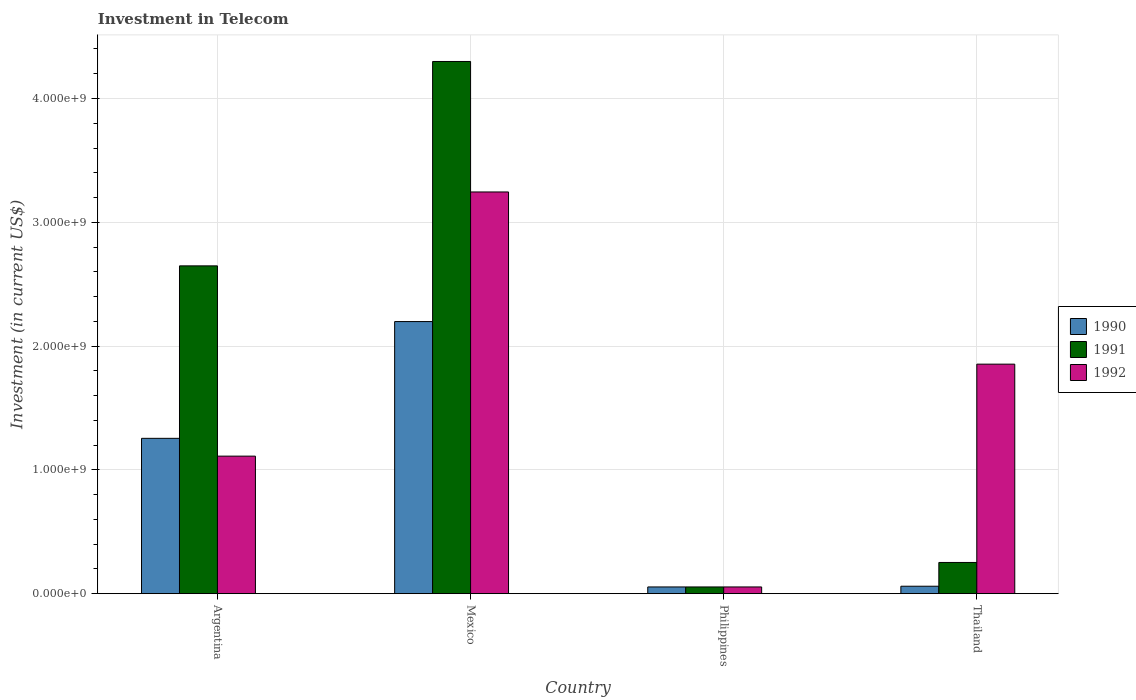Are the number of bars per tick equal to the number of legend labels?
Ensure brevity in your answer.  Yes. Are the number of bars on each tick of the X-axis equal?
Your response must be concise. Yes. How many bars are there on the 2nd tick from the right?
Your answer should be compact. 3. What is the amount invested in telecom in 1990 in Argentina?
Ensure brevity in your answer.  1.25e+09. Across all countries, what is the maximum amount invested in telecom in 1990?
Keep it short and to the point. 2.20e+09. Across all countries, what is the minimum amount invested in telecom in 1991?
Offer a very short reply. 5.42e+07. In which country was the amount invested in telecom in 1992 maximum?
Your answer should be compact. Mexico. In which country was the amount invested in telecom in 1990 minimum?
Ensure brevity in your answer.  Philippines. What is the total amount invested in telecom in 1992 in the graph?
Make the answer very short. 6.26e+09. What is the difference between the amount invested in telecom in 1991 in Mexico and that in Thailand?
Your response must be concise. 4.05e+09. What is the difference between the amount invested in telecom in 1991 in Thailand and the amount invested in telecom in 1992 in Mexico?
Offer a very short reply. -2.99e+09. What is the average amount invested in telecom in 1990 per country?
Provide a short and direct response. 8.92e+08. What is the difference between the amount invested in telecom of/in 1990 and amount invested in telecom of/in 1991 in Argentina?
Provide a succinct answer. -1.39e+09. In how many countries, is the amount invested in telecom in 1992 greater than 3200000000 US$?
Make the answer very short. 1. What is the ratio of the amount invested in telecom in 1992 in Argentina to that in Thailand?
Give a very brief answer. 0.6. Is the amount invested in telecom in 1990 in Philippines less than that in Thailand?
Your answer should be compact. Yes. Is the difference between the amount invested in telecom in 1990 in Argentina and Philippines greater than the difference between the amount invested in telecom in 1991 in Argentina and Philippines?
Your answer should be compact. No. What is the difference between the highest and the second highest amount invested in telecom in 1990?
Make the answer very short. 2.14e+09. What is the difference between the highest and the lowest amount invested in telecom in 1992?
Ensure brevity in your answer.  3.19e+09. Is it the case that in every country, the sum of the amount invested in telecom in 1992 and amount invested in telecom in 1990 is greater than the amount invested in telecom in 1991?
Ensure brevity in your answer.  No. What is the difference between two consecutive major ticks on the Y-axis?
Offer a very short reply. 1.00e+09. Are the values on the major ticks of Y-axis written in scientific E-notation?
Offer a very short reply. Yes. Does the graph contain grids?
Provide a succinct answer. Yes. What is the title of the graph?
Provide a succinct answer. Investment in Telecom. Does "2009" appear as one of the legend labels in the graph?
Offer a very short reply. No. What is the label or title of the X-axis?
Your answer should be compact. Country. What is the label or title of the Y-axis?
Offer a very short reply. Investment (in current US$). What is the Investment (in current US$) in 1990 in Argentina?
Offer a terse response. 1.25e+09. What is the Investment (in current US$) of 1991 in Argentina?
Your answer should be compact. 2.65e+09. What is the Investment (in current US$) in 1992 in Argentina?
Your answer should be compact. 1.11e+09. What is the Investment (in current US$) in 1990 in Mexico?
Give a very brief answer. 2.20e+09. What is the Investment (in current US$) in 1991 in Mexico?
Provide a short and direct response. 4.30e+09. What is the Investment (in current US$) in 1992 in Mexico?
Offer a terse response. 3.24e+09. What is the Investment (in current US$) in 1990 in Philippines?
Provide a succinct answer. 5.42e+07. What is the Investment (in current US$) of 1991 in Philippines?
Your answer should be very brief. 5.42e+07. What is the Investment (in current US$) in 1992 in Philippines?
Ensure brevity in your answer.  5.42e+07. What is the Investment (in current US$) of 1990 in Thailand?
Your response must be concise. 6.00e+07. What is the Investment (in current US$) in 1991 in Thailand?
Provide a succinct answer. 2.52e+08. What is the Investment (in current US$) in 1992 in Thailand?
Offer a terse response. 1.85e+09. Across all countries, what is the maximum Investment (in current US$) in 1990?
Your response must be concise. 2.20e+09. Across all countries, what is the maximum Investment (in current US$) in 1991?
Make the answer very short. 4.30e+09. Across all countries, what is the maximum Investment (in current US$) in 1992?
Ensure brevity in your answer.  3.24e+09. Across all countries, what is the minimum Investment (in current US$) in 1990?
Keep it short and to the point. 5.42e+07. Across all countries, what is the minimum Investment (in current US$) of 1991?
Keep it short and to the point. 5.42e+07. Across all countries, what is the minimum Investment (in current US$) of 1992?
Offer a very short reply. 5.42e+07. What is the total Investment (in current US$) of 1990 in the graph?
Provide a succinct answer. 3.57e+09. What is the total Investment (in current US$) in 1991 in the graph?
Make the answer very short. 7.25e+09. What is the total Investment (in current US$) in 1992 in the graph?
Provide a succinct answer. 6.26e+09. What is the difference between the Investment (in current US$) of 1990 in Argentina and that in Mexico?
Keep it short and to the point. -9.43e+08. What is the difference between the Investment (in current US$) of 1991 in Argentina and that in Mexico?
Your answer should be compact. -1.65e+09. What is the difference between the Investment (in current US$) of 1992 in Argentina and that in Mexico?
Ensure brevity in your answer.  -2.13e+09. What is the difference between the Investment (in current US$) of 1990 in Argentina and that in Philippines?
Make the answer very short. 1.20e+09. What is the difference between the Investment (in current US$) in 1991 in Argentina and that in Philippines?
Give a very brief answer. 2.59e+09. What is the difference between the Investment (in current US$) of 1992 in Argentina and that in Philippines?
Make the answer very short. 1.06e+09. What is the difference between the Investment (in current US$) of 1990 in Argentina and that in Thailand?
Offer a very short reply. 1.19e+09. What is the difference between the Investment (in current US$) in 1991 in Argentina and that in Thailand?
Offer a very short reply. 2.40e+09. What is the difference between the Investment (in current US$) in 1992 in Argentina and that in Thailand?
Your answer should be very brief. -7.43e+08. What is the difference between the Investment (in current US$) in 1990 in Mexico and that in Philippines?
Ensure brevity in your answer.  2.14e+09. What is the difference between the Investment (in current US$) in 1991 in Mexico and that in Philippines?
Your response must be concise. 4.24e+09. What is the difference between the Investment (in current US$) in 1992 in Mexico and that in Philippines?
Your answer should be very brief. 3.19e+09. What is the difference between the Investment (in current US$) in 1990 in Mexico and that in Thailand?
Offer a terse response. 2.14e+09. What is the difference between the Investment (in current US$) of 1991 in Mexico and that in Thailand?
Your answer should be very brief. 4.05e+09. What is the difference between the Investment (in current US$) in 1992 in Mexico and that in Thailand?
Make the answer very short. 1.39e+09. What is the difference between the Investment (in current US$) in 1990 in Philippines and that in Thailand?
Make the answer very short. -5.80e+06. What is the difference between the Investment (in current US$) in 1991 in Philippines and that in Thailand?
Your answer should be very brief. -1.98e+08. What is the difference between the Investment (in current US$) of 1992 in Philippines and that in Thailand?
Ensure brevity in your answer.  -1.80e+09. What is the difference between the Investment (in current US$) of 1990 in Argentina and the Investment (in current US$) of 1991 in Mexico?
Give a very brief answer. -3.04e+09. What is the difference between the Investment (in current US$) in 1990 in Argentina and the Investment (in current US$) in 1992 in Mexico?
Give a very brief answer. -1.99e+09. What is the difference between the Investment (in current US$) of 1991 in Argentina and the Investment (in current US$) of 1992 in Mexico?
Give a very brief answer. -5.97e+08. What is the difference between the Investment (in current US$) of 1990 in Argentina and the Investment (in current US$) of 1991 in Philippines?
Your answer should be very brief. 1.20e+09. What is the difference between the Investment (in current US$) of 1990 in Argentina and the Investment (in current US$) of 1992 in Philippines?
Offer a terse response. 1.20e+09. What is the difference between the Investment (in current US$) of 1991 in Argentina and the Investment (in current US$) of 1992 in Philippines?
Your response must be concise. 2.59e+09. What is the difference between the Investment (in current US$) in 1990 in Argentina and the Investment (in current US$) in 1991 in Thailand?
Make the answer very short. 1.00e+09. What is the difference between the Investment (in current US$) of 1990 in Argentina and the Investment (in current US$) of 1992 in Thailand?
Give a very brief answer. -5.99e+08. What is the difference between the Investment (in current US$) in 1991 in Argentina and the Investment (in current US$) in 1992 in Thailand?
Offer a very short reply. 7.94e+08. What is the difference between the Investment (in current US$) in 1990 in Mexico and the Investment (in current US$) in 1991 in Philippines?
Your answer should be compact. 2.14e+09. What is the difference between the Investment (in current US$) in 1990 in Mexico and the Investment (in current US$) in 1992 in Philippines?
Make the answer very short. 2.14e+09. What is the difference between the Investment (in current US$) in 1991 in Mexico and the Investment (in current US$) in 1992 in Philippines?
Give a very brief answer. 4.24e+09. What is the difference between the Investment (in current US$) in 1990 in Mexico and the Investment (in current US$) in 1991 in Thailand?
Your response must be concise. 1.95e+09. What is the difference between the Investment (in current US$) in 1990 in Mexico and the Investment (in current US$) in 1992 in Thailand?
Your response must be concise. 3.44e+08. What is the difference between the Investment (in current US$) of 1991 in Mexico and the Investment (in current US$) of 1992 in Thailand?
Give a very brief answer. 2.44e+09. What is the difference between the Investment (in current US$) in 1990 in Philippines and the Investment (in current US$) in 1991 in Thailand?
Your answer should be compact. -1.98e+08. What is the difference between the Investment (in current US$) in 1990 in Philippines and the Investment (in current US$) in 1992 in Thailand?
Offer a terse response. -1.80e+09. What is the difference between the Investment (in current US$) in 1991 in Philippines and the Investment (in current US$) in 1992 in Thailand?
Ensure brevity in your answer.  -1.80e+09. What is the average Investment (in current US$) of 1990 per country?
Give a very brief answer. 8.92e+08. What is the average Investment (in current US$) of 1991 per country?
Your answer should be very brief. 1.81e+09. What is the average Investment (in current US$) of 1992 per country?
Keep it short and to the point. 1.57e+09. What is the difference between the Investment (in current US$) in 1990 and Investment (in current US$) in 1991 in Argentina?
Provide a short and direct response. -1.39e+09. What is the difference between the Investment (in current US$) in 1990 and Investment (in current US$) in 1992 in Argentina?
Your answer should be compact. 1.44e+08. What is the difference between the Investment (in current US$) of 1991 and Investment (in current US$) of 1992 in Argentina?
Your answer should be very brief. 1.54e+09. What is the difference between the Investment (in current US$) in 1990 and Investment (in current US$) in 1991 in Mexico?
Offer a very short reply. -2.10e+09. What is the difference between the Investment (in current US$) in 1990 and Investment (in current US$) in 1992 in Mexico?
Your answer should be very brief. -1.05e+09. What is the difference between the Investment (in current US$) of 1991 and Investment (in current US$) of 1992 in Mexico?
Provide a short and direct response. 1.05e+09. What is the difference between the Investment (in current US$) of 1990 and Investment (in current US$) of 1991 in Philippines?
Keep it short and to the point. 0. What is the difference between the Investment (in current US$) of 1991 and Investment (in current US$) of 1992 in Philippines?
Keep it short and to the point. 0. What is the difference between the Investment (in current US$) in 1990 and Investment (in current US$) in 1991 in Thailand?
Your answer should be very brief. -1.92e+08. What is the difference between the Investment (in current US$) in 1990 and Investment (in current US$) in 1992 in Thailand?
Your answer should be compact. -1.79e+09. What is the difference between the Investment (in current US$) in 1991 and Investment (in current US$) in 1992 in Thailand?
Ensure brevity in your answer.  -1.60e+09. What is the ratio of the Investment (in current US$) of 1990 in Argentina to that in Mexico?
Keep it short and to the point. 0.57. What is the ratio of the Investment (in current US$) in 1991 in Argentina to that in Mexico?
Give a very brief answer. 0.62. What is the ratio of the Investment (in current US$) of 1992 in Argentina to that in Mexico?
Give a very brief answer. 0.34. What is the ratio of the Investment (in current US$) of 1990 in Argentina to that in Philippines?
Keep it short and to the point. 23.15. What is the ratio of the Investment (in current US$) in 1991 in Argentina to that in Philippines?
Offer a very short reply. 48.86. What is the ratio of the Investment (in current US$) in 1992 in Argentina to that in Philippines?
Give a very brief answer. 20.5. What is the ratio of the Investment (in current US$) in 1990 in Argentina to that in Thailand?
Give a very brief answer. 20.91. What is the ratio of the Investment (in current US$) of 1991 in Argentina to that in Thailand?
Your answer should be compact. 10.51. What is the ratio of the Investment (in current US$) in 1992 in Argentina to that in Thailand?
Your response must be concise. 0.6. What is the ratio of the Investment (in current US$) of 1990 in Mexico to that in Philippines?
Your answer should be very brief. 40.55. What is the ratio of the Investment (in current US$) of 1991 in Mexico to that in Philippines?
Keep it short and to the point. 79.32. What is the ratio of the Investment (in current US$) in 1992 in Mexico to that in Philippines?
Ensure brevity in your answer.  59.87. What is the ratio of the Investment (in current US$) in 1990 in Mexico to that in Thailand?
Offer a terse response. 36.63. What is the ratio of the Investment (in current US$) of 1991 in Mexico to that in Thailand?
Provide a short and direct response. 17.06. What is the ratio of the Investment (in current US$) of 1992 in Mexico to that in Thailand?
Give a very brief answer. 1.75. What is the ratio of the Investment (in current US$) in 1990 in Philippines to that in Thailand?
Provide a succinct answer. 0.9. What is the ratio of the Investment (in current US$) of 1991 in Philippines to that in Thailand?
Keep it short and to the point. 0.22. What is the ratio of the Investment (in current US$) in 1992 in Philippines to that in Thailand?
Offer a terse response. 0.03. What is the difference between the highest and the second highest Investment (in current US$) in 1990?
Offer a very short reply. 9.43e+08. What is the difference between the highest and the second highest Investment (in current US$) in 1991?
Provide a succinct answer. 1.65e+09. What is the difference between the highest and the second highest Investment (in current US$) in 1992?
Make the answer very short. 1.39e+09. What is the difference between the highest and the lowest Investment (in current US$) of 1990?
Offer a terse response. 2.14e+09. What is the difference between the highest and the lowest Investment (in current US$) of 1991?
Make the answer very short. 4.24e+09. What is the difference between the highest and the lowest Investment (in current US$) of 1992?
Your answer should be very brief. 3.19e+09. 